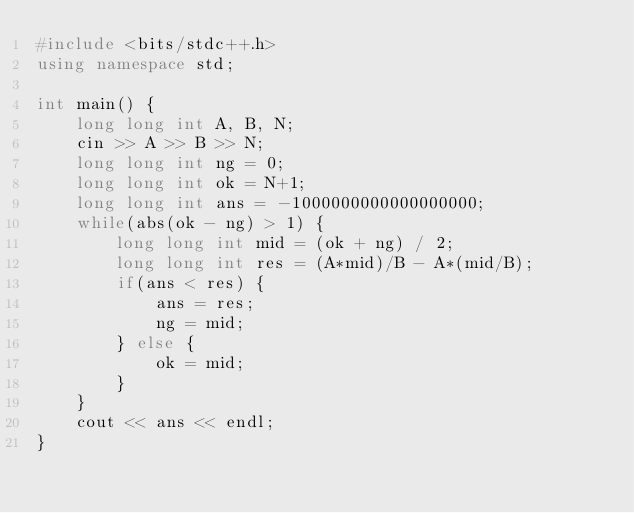Convert code to text. <code><loc_0><loc_0><loc_500><loc_500><_C++_>#include <bits/stdc++.h>
using namespace std;

int main() {
    long long int A, B, N;
    cin >> A >> B >> N;
    long long int ng = 0;
    long long int ok = N+1;
    long long int ans = -1000000000000000000;
    while(abs(ok - ng) > 1) {
        long long int mid = (ok + ng) / 2;
        long long int res = (A*mid)/B - A*(mid/B);
        if(ans < res) {
            ans = res;
            ng = mid;
        } else {
            ok = mid;
        }
    }
    cout << ans << endl;
}</code> 